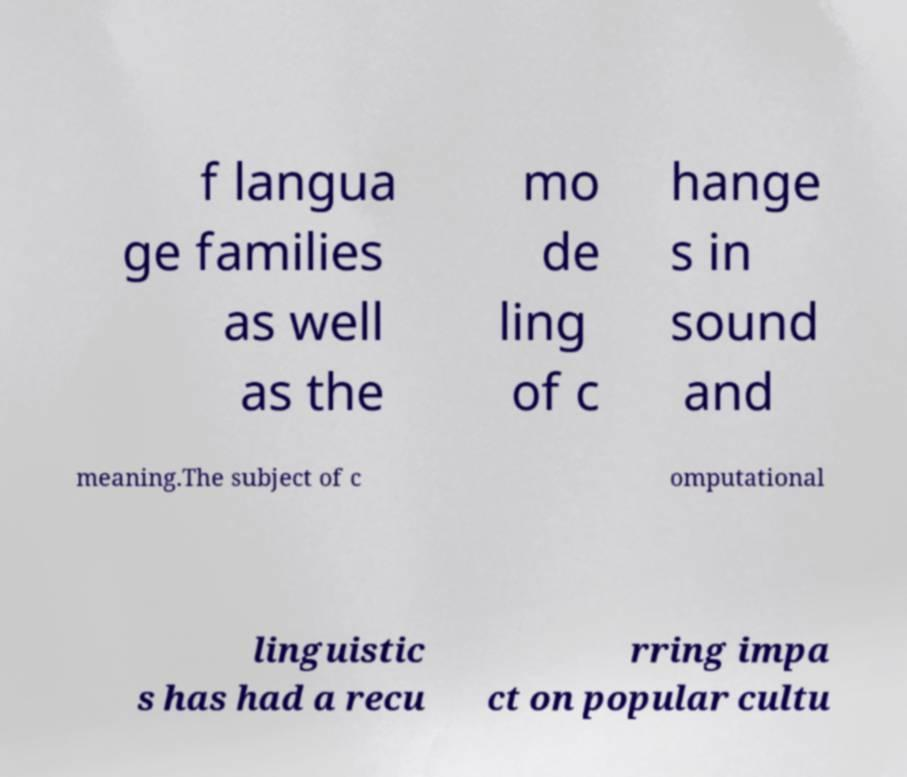Please identify and transcribe the text found in this image. f langua ge families as well as the mo de ling of c hange s in sound and meaning.The subject of c omputational linguistic s has had a recu rring impa ct on popular cultu 